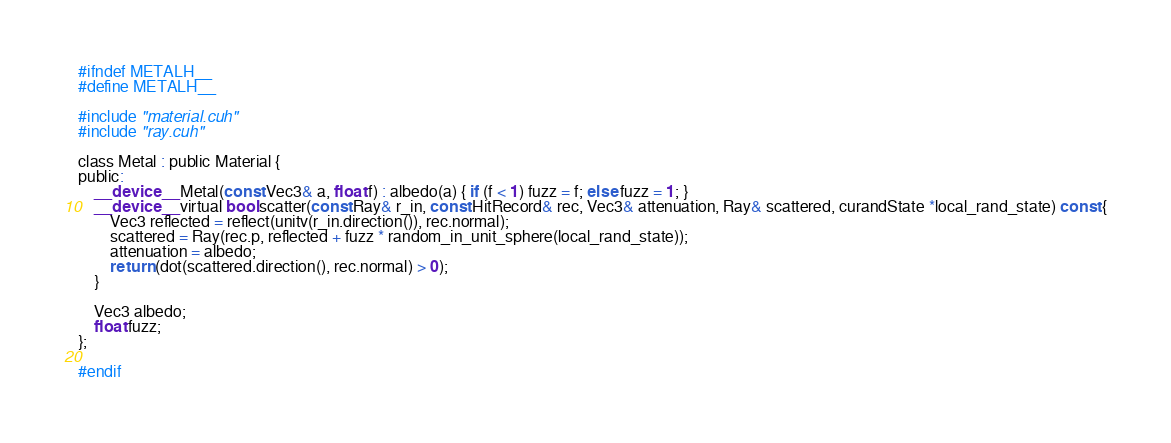Convert code to text. <code><loc_0><loc_0><loc_500><loc_500><_Cuda_>#ifndef METALH__
#define METALH__

#include "material.cuh"
#include "ray.cuh"

class Metal : public Material {
public:
    __device__ Metal(const Vec3& a, float f) : albedo(a) { if (f < 1) fuzz = f; else fuzz = 1; }
    __device__ virtual bool scatter(const Ray& r_in, const HitRecord& rec, Vec3& attenuation, Ray& scattered, curandState *local_rand_state) const {
        Vec3 reflected = reflect(unitv(r_in.direction()), rec.normal);
        scattered = Ray(rec.p, reflected + fuzz * random_in_unit_sphere(local_rand_state));
        attenuation = albedo;
        return (dot(scattered.direction(), rec.normal) > 0);
    }

    Vec3 albedo;
    float fuzz;
};

#endif</code> 